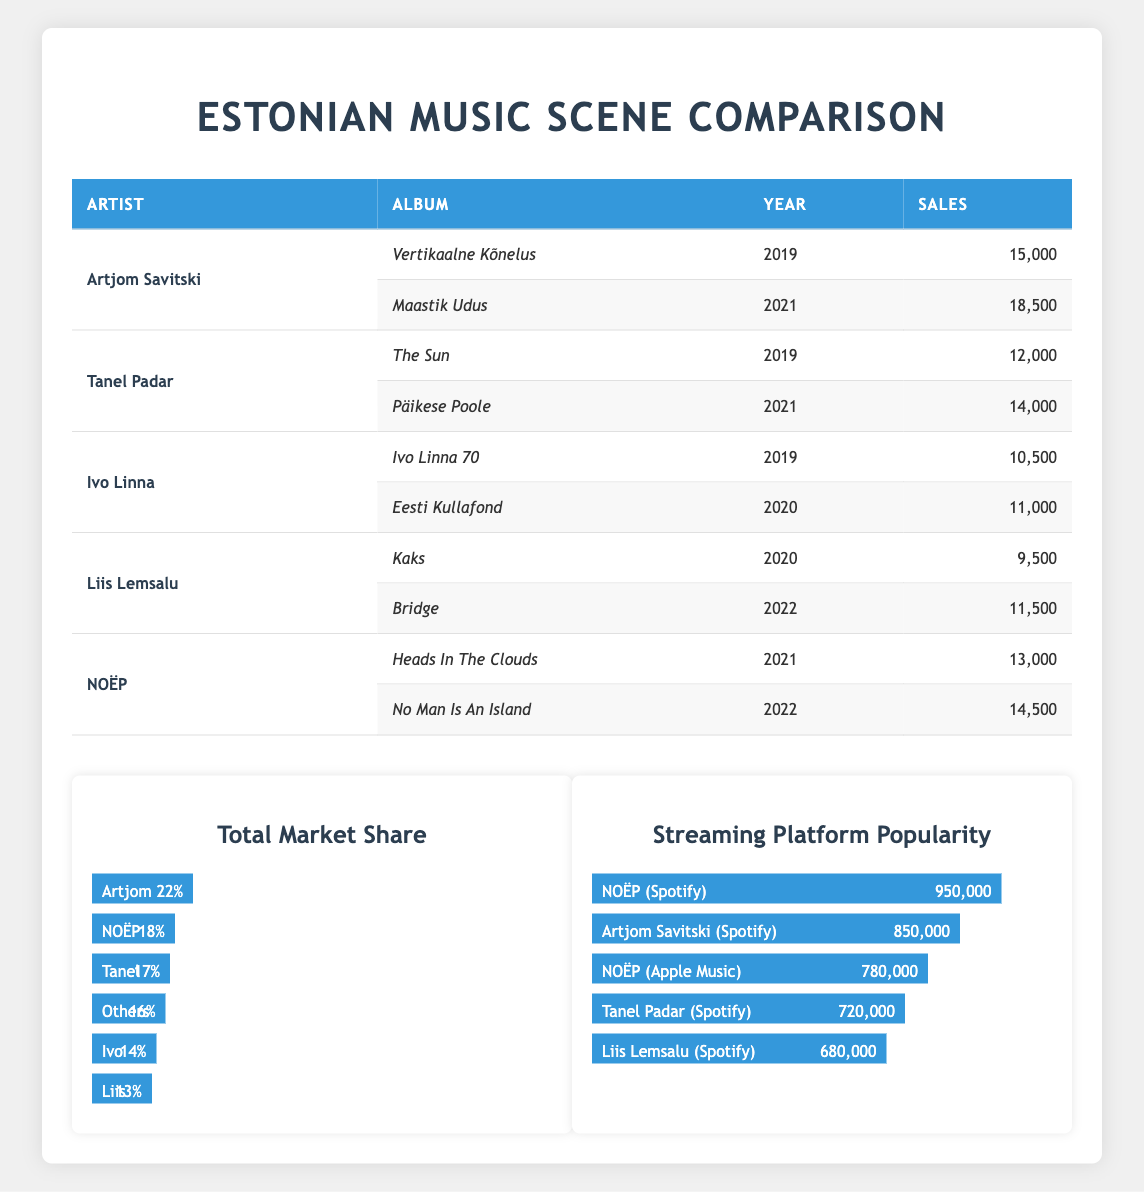What is the total sales of Artjom Savitski's albums? Artjom Savitski has released two albums: "Vertikaalne Kõnelus" with sales of 15,000 and "Maastik Udus" with sales of 18,500. To find the total sales, we add these two numbers: 15,000 + 18,500 = 33,500.
Answer: 33,500 Which artist has the highest album sales in a single year? Looking at the sales figures for each album, Artjom Savitski’s "Maastik Udus" has the highest sales with 18,500 in 2021, compared to other artists' best-selling albums in the same year or others.
Answer: Artjom Savitski What is the average album sales for the artists listed? The total album sales for all artists combined is (15,000 + 18,500 + 12,000 + 14,000 + 10,500 + 11,000 + 9,500 + 11,500 + 13,000 + 14,500) =  130,000. Since there are 10 albums in total, the average sales are 130,000/10 = 13,000.
Answer: 13,000 Is Liis Lemsalu's total album sales greater than Tanel Padar's? Liis Lemsalu has sales of (9,500 + 11,500) = 21,000 while Tanel Padar has sales of (12,000 + 14,000) = 26,000. Therefore, 21,000 is less than 26,000.
Answer: No Which artist has the smallest total market share? By reviewing the total market share percentages provided, Ivo Linna has a market share of 14%, which is the smallest among all listed artists.
Answer: Ivo Linna 